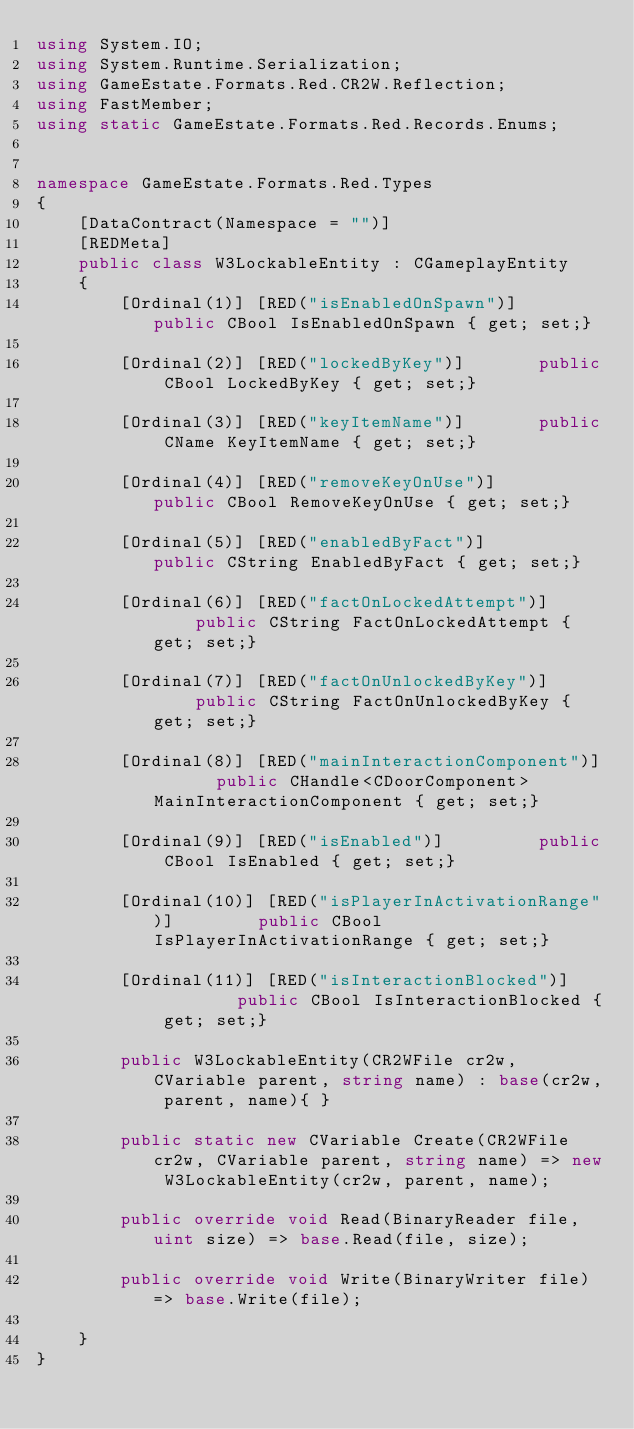<code> <loc_0><loc_0><loc_500><loc_500><_C#_>using System.IO;
using System.Runtime.Serialization;
using GameEstate.Formats.Red.CR2W.Reflection;
using FastMember;
using static GameEstate.Formats.Red.Records.Enums;


namespace GameEstate.Formats.Red.Types
{
	[DataContract(Namespace = "")]
	[REDMeta]
	public class W3LockableEntity : CGameplayEntity
	{
		[Ordinal(1)] [RED("isEnabledOnSpawn")] 		public CBool IsEnabledOnSpawn { get; set;}

		[Ordinal(2)] [RED("lockedByKey")] 		public CBool LockedByKey { get; set;}

		[Ordinal(3)] [RED("keyItemName")] 		public CName KeyItemName { get; set;}

		[Ordinal(4)] [RED("removeKeyOnUse")] 		public CBool RemoveKeyOnUse { get; set;}

		[Ordinal(5)] [RED("enabledByFact")] 		public CString EnabledByFact { get; set;}

		[Ordinal(6)] [RED("factOnLockedAttempt")] 		public CString FactOnLockedAttempt { get; set;}

		[Ordinal(7)] [RED("factOnUnlockedByKey")] 		public CString FactOnUnlockedByKey { get; set;}

		[Ordinal(8)] [RED("mainInteractionComponent")] 		public CHandle<CDoorComponent> MainInteractionComponent { get; set;}

		[Ordinal(9)] [RED("isEnabled")] 		public CBool IsEnabled { get; set;}

		[Ordinal(10)] [RED("isPlayerInActivationRange")] 		public CBool IsPlayerInActivationRange { get; set;}

		[Ordinal(11)] [RED("isInteractionBlocked")] 		public CBool IsInteractionBlocked { get; set;}

		public W3LockableEntity(CR2WFile cr2w, CVariable parent, string name) : base(cr2w, parent, name){ }

		public static new CVariable Create(CR2WFile cr2w, CVariable parent, string name) => new W3LockableEntity(cr2w, parent, name);

		public override void Read(BinaryReader file, uint size) => base.Read(file, size);

		public override void Write(BinaryWriter file) => base.Write(file);

	}
}</code> 